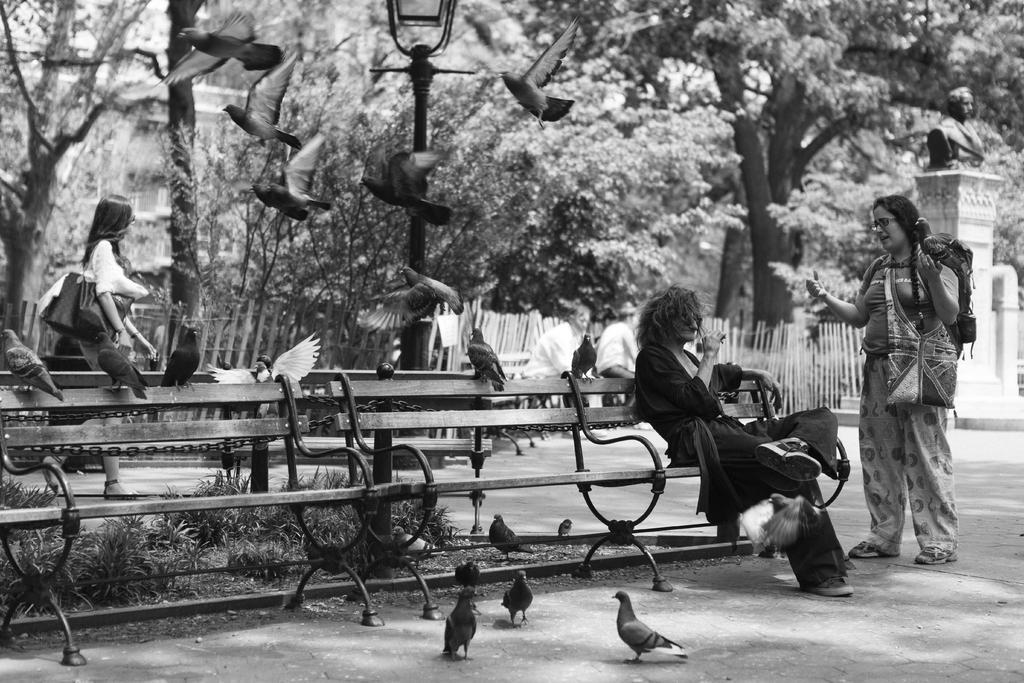Describe this image in one or two sentences. This is a black and white image. A person is sitting on bench. Beside to him a woman is standing. There are few birds on the ground and few birds are flying in the air. There is a woman at left side of the image walking behind the bench. Background there is a fence and trees. There is a statue at the right side of the image. Two persons are sitting before the fence. Few plants are there at the backside of the bench. 